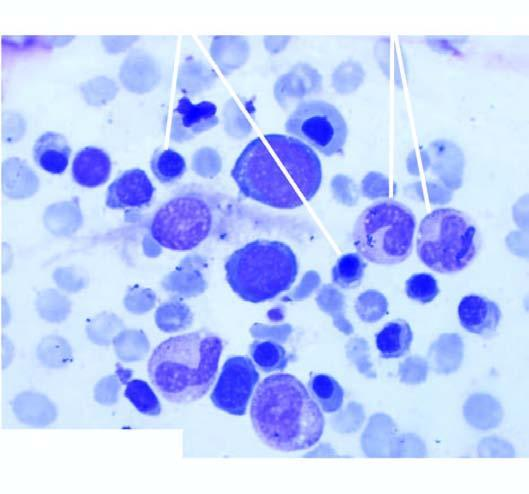s there moderate microcytosis and hypochromia?
Answer the question using a single word or phrase. Yes 